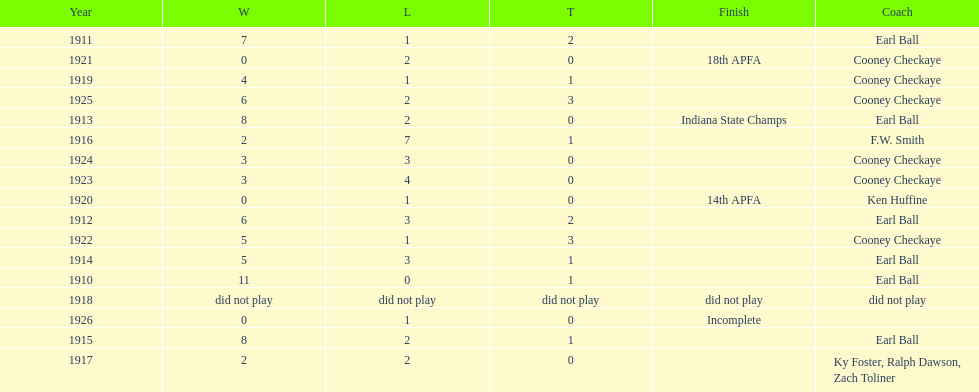Who coached the muncie flyers to an indiana state championship? Earl Ball. 